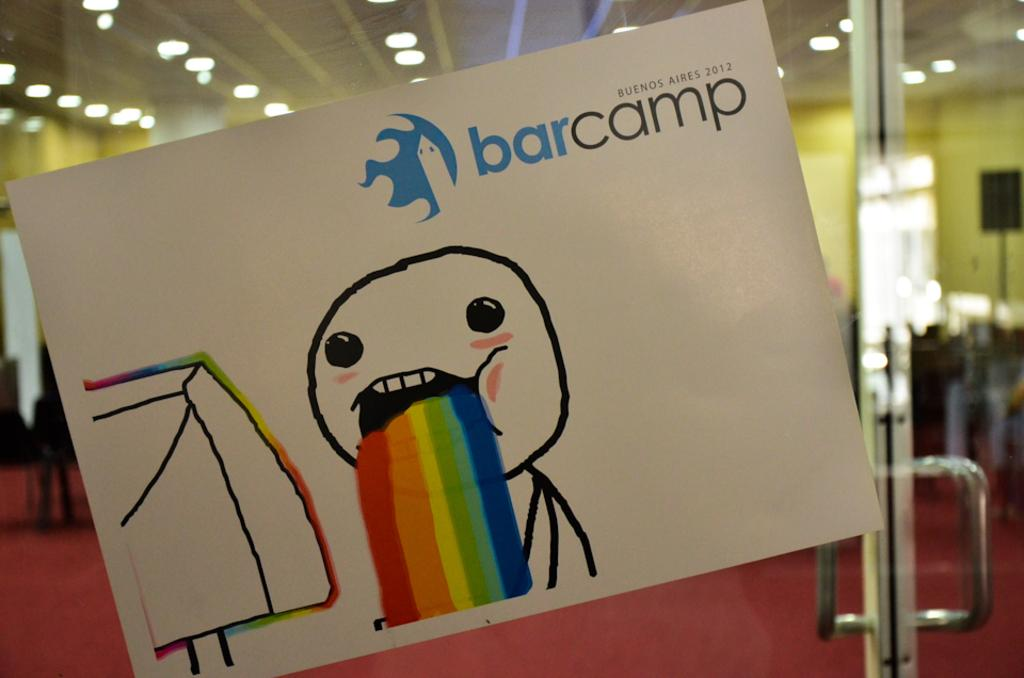<image>
Present a compact description of the photo's key features. bar camp in Buenes Aires in the year 2012 